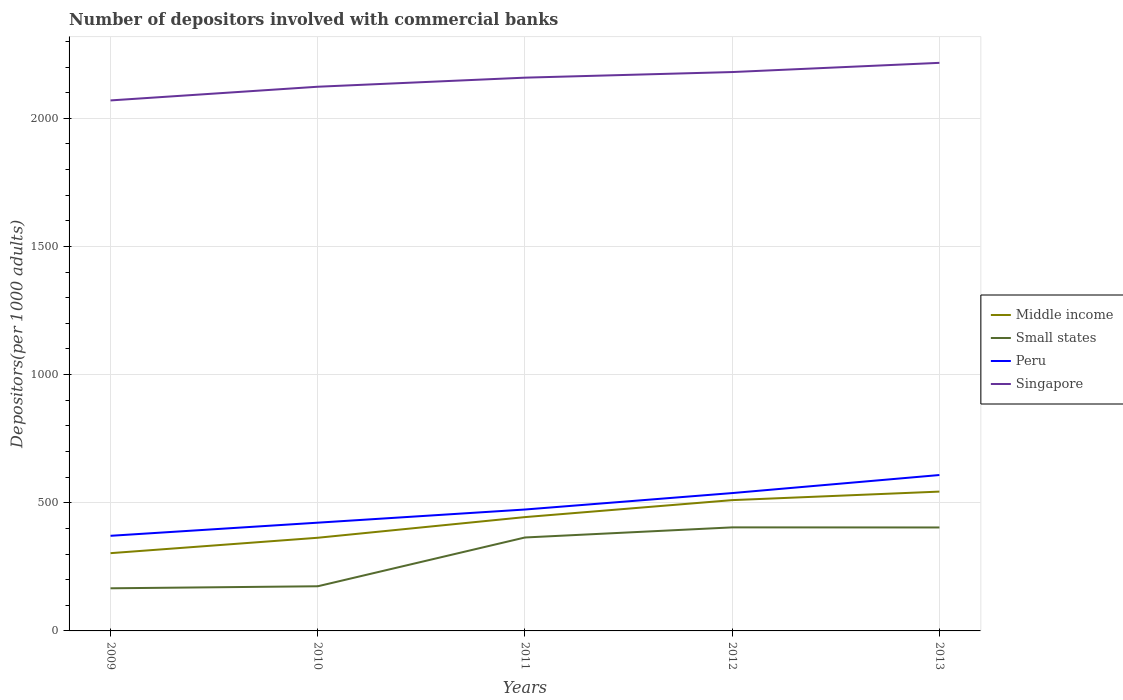How many different coloured lines are there?
Offer a very short reply. 4. Across all years, what is the maximum number of depositors involved with commercial banks in Singapore?
Provide a succinct answer. 2069.88. In which year was the number of depositors involved with commercial banks in Singapore maximum?
Provide a succinct answer. 2009. What is the total number of depositors involved with commercial banks in Singapore in the graph?
Ensure brevity in your answer.  -53.4. What is the difference between the highest and the second highest number of depositors involved with commercial banks in Small states?
Provide a succinct answer. 237.71. Is the number of depositors involved with commercial banks in Singapore strictly greater than the number of depositors involved with commercial banks in Peru over the years?
Keep it short and to the point. No. How many lines are there?
Give a very brief answer. 4. What is the difference between two consecutive major ticks on the Y-axis?
Provide a short and direct response. 500. Are the values on the major ticks of Y-axis written in scientific E-notation?
Offer a terse response. No. Does the graph contain grids?
Offer a terse response. Yes. How many legend labels are there?
Your response must be concise. 4. What is the title of the graph?
Keep it short and to the point. Number of depositors involved with commercial banks. Does "Armenia" appear as one of the legend labels in the graph?
Offer a very short reply. No. What is the label or title of the X-axis?
Keep it short and to the point. Years. What is the label or title of the Y-axis?
Provide a succinct answer. Depositors(per 1000 adults). What is the Depositors(per 1000 adults) of Middle income in 2009?
Make the answer very short. 303.38. What is the Depositors(per 1000 adults) in Small states in 2009?
Keep it short and to the point. 166.31. What is the Depositors(per 1000 adults) of Peru in 2009?
Offer a very short reply. 371.13. What is the Depositors(per 1000 adults) in Singapore in 2009?
Make the answer very short. 2069.88. What is the Depositors(per 1000 adults) in Middle income in 2010?
Make the answer very short. 363.5. What is the Depositors(per 1000 adults) in Small states in 2010?
Ensure brevity in your answer.  174.21. What is the Depositors(per 1000 adults) of Peru in 2010?
Offer a very short reply. 422.34. What is the Depositors(per 1000 adults) in Singapore in 2010?
Offer a terse response. 2123.28. What is the Depositors(per 1000 adults) in Middle income in 2011?
Your response must be concise. 444.11. What is the Depositors(per 1000 adults) in Small states in 2011?
Make the answer very short. 364.57. What is the Depositors(per 1000 adults) in Peru in 2011?
Offer a very short reply. 473.69. What is the Depositors(per 1000 adults) in Singapore in 2011?
Offer a very short reply. 2158.7. What is the Depositors(per 1000 adults) in Middle income in 2012?
Give a very brief answer. 510.34. What is the Depositors(per 1000 adults) of Small states in 2012?
Ensure brevity in your answer.  404.02. What is the Depositors(per 1000 adults) in Peru in 2012?
Give a very brief answer. 537.87. What is the Depositors(per 1000 adults) of Singapore in 2012?
Provide a succinct answer. 2180.57. What is the Depositors(per 1000 adults) in Middle income in 2013?
Make the answer very short. 543.59. What is the Depositors(per 1000 adults) in Small states in 2013?
Provide a short and direct response. 403.64. What is the Depositors(per 1000 adults) in Peru in 2013?
Your response must be concise. 608.29. What is the Depositors(per 1000 adults) of Singapore in 2013?
Your answer should be very brief. 2216.49. Across all years, what is the maximum Depositors(per 1000 adults) in Middle income?
Give a very brief answer. 543.59. Across all years, what is the maximum Depositors(per 1000 adults) in Small states?
Offer a very short reply. 404.02. Across all years, what is the maximum Depositors(per 1000 adults) of Peru?
Provide a short and direct response. 608.29. Across all years, what is the maximum Depositors(per 1000 adults) of Singapore?
Keep it short and to the point. 2216.49. Across all years, what is the minimum Depositors(per 1000 adults) in Middle income?
Your answer should be very brief. 303.38. Across all years, what is the minimum Depositors(per 1000 adults) of Small states?
Make the answer very short. 166.31. Across all years, what is the minimum Depositors(per 1000 adults) of Peru?
Give a very brief answer. 371.13. Across all years, what is the minimum Depositors(per 1000 adults) in Singapore?
Provide a short and direct response. 2069.88. What is the total Depositors(per 1000 adults) in Middle income in the graph?
Make the answer very short. 2164.92. What is the total Depositors(per 1000 adults) of Small states in the graph?
Your answer should be very brief. 1512.74. What is the total Depositors(per 1000 adults) of Peru in the graph?
Give a very brief answer. 2413.33. What is the total Depositors(per 1000 adults) in Singapore in the graph?
Your response must be concise. 1.07e+04. What is the difference between the Depositors(per 1000 adults) of Middle income in 2009 and that in 2010?
Make the answer very short. -60.11. What is the difference between the Depositors(per 1000 adults) of Small states in 2009 and that in 2010?
Your answer should be compact. -7.91. What is the difference between the Depositors(per 1000 adults) of Peru in 2009 and that in 2010?
Your answer should be very brief. -51.21. What is the difference between the Depositors(per 1000 adults) in Singapore in 2009 and that in 2010?
Offer a very short reply. -53.4. What is the difference between the Depositors(per 1000 adults) of Middle income in 2009 and that in 2011?
Your response must be concise. -140.73. What is the difference between the Depositors(per 1000 adults) in Small states in 2009 and that in 2011?
Your answer should be compact. -198.26. What is the difference between the Depositors(per 1000 adults) in Peru in 2009 and that in 2011?
Your answer should be very brief. -102.56. What is the difference between the Depositors(per 1000 adults) in Singapore in 2009 and that in 2011?
Ensure brevity in your answer.  -88.82. What is the difference between the Depositors(per 1000 adults) in Middle income in 2009 and that in 2012?
Provide a short and direct response. -206.95. What is the difference between the Depositors(per 1000 adults) of Small states in 2009 and that in 2012?
Offer a very short reply. -237.71. What is the difference between the Depositors(per 1000 adults) in Peru in 2009 and that in 2012?
Ensure brevity in your answer.  -166.74. What is the difference between the Depositors(per 1000 adults) in Singapore in 2009 and that in 2012?
Ensure brevity in your answer.  -110.69. What is the difference between the Depositors(per 1000 adults) of Middle income in 2009 and that in 2013?
Your answer should be compact. -240.21. What is the difference between the Depositors(per 1000 adults) in Small states in 2009 and that in 2013?
Give a very brief answer. -237.33. What is the difference between the Depositors(per 1000 adults) in Peru in 2009 and that in 2013?
Provide a short and direct response. -237.16. What is the difference between the Depositors(per 1000 adults) of Singapore in 2009 and that in 2013?
Offer a terse response. -146.61. What is the difference between the Depositors(per 1000 adults) in Middle income in 2010 and that in 2011?
Your answer should be compact. -80.61. What is the difference between the Depositors(per 1000 adults) of Small states in 2010 and that in 2011?
Offer a very short reply. -190.35. What is the difference between the Depositors(per 1000 adults) in Peru in 2010 and that in 2011?
Your response must be concise. -51.35. What is the difference between the Depositors(per 1000 adults) of Singapore in 2010 and that in 2011?
Provide a short and direct response. -35.42. What is the difference between the Depositors(per 1000 adults) in Middle income in 2010 and that in 2012?
Give a very brief answer. -146.84. What is the difference between the Depositors(per 1000 adults) of Small states in 2010 and that in 2012?
Ensure brevity in your answer.  -229.8. What is the difference between the Depositors(per 1000 adults) of Peru in 2010 and that in 2012?
Your response must be concise. -115.53. What is the difference between the Depositors(per 1000 adults) of Singapore in 2010 and that in 2012?
Offer a very short reply. -57.29. What is the difference between the Depositors(per 1000 adults) of Middle income in 2010 and that in 2013?
Your answer should be very brief. -180.09. What is the difference between the Depositors(per 1000 adults) of Small states in 2010 and that in 2013?
Keep it short and to the point. -229.42. What is the difference between the Depositors(per 1000 adults) of Peru in 2010 and that in 2013?
Your answer should be very brief. -185.95. What is the difference between the Depositors(per 1000 adults) in Singapore in 2010 and that in 2013?
Offer a very short reply. -93.21. What is the difference between the Depositors(per 1000 adults) of Middle income in 2011 and that in 2012?
Ensure brevity in your answer.  -66.23. What is the difference between the Depositors(per 1000 adults) of Small states in 2011 and that in 2012?
Your answer should be compact. -39.45. What is the difference between the Depositors(per 1000 adults) of Peru in 2011 and that in 2012?
Make the answer very short. -64.18. What is the difference between the Depositors(per 1000 adults) in Singapore in 2011 and that in 2012?
Make the answer very short. -21.87. What is the difference between the Depositors(per 1000 adults) of Middle income in 2011 and that in 2013?
Offer a very short reply. -99.48. What is the difference between the Depositors(per 1000 adults) in Small states in 2011 and that in 2013?
Offer a very short reply. -39.07. What is the difference between the Depositors(per 1000 adults) of Peru in 2011 and that in 2013?
Your answer should be very brief. -134.6. What is the difference between the Depositors(per 1000 adults) in Singapore in 2011 and that in 2013?
Offer a terse response. -57.79. What is the difference between the Depositors(per 1000 adults) in Middle income in 2012 and that in 2013?
Give a very brief answer. -33.25. What is the difference between the Depositors(per 1000 adults) in Small states in 2012 and that in 2013?
Provide a succinct answer. 0.38. What is the difference between the Depositors(per 1000 adults) in Peru in 2012 and that in 2013?
Provide a succinct answer. -70.42. What is the difference between the Depositors(per 1000 adults) in Singapore in 2012 and that in 2013?
Offer a very short reply. -35.92. What is the difference between the Depositors(per 1000 adults) in Middle income in 2009 and the Depositors(per 1000 adults) in Small states in 2010?
Provide a short and direct response. 129.17. What is the difference between the Depositors(per 1000 adults) of Middle income in 2009 and the Depositors(per 1000 adults) of Peru in 2010?
Ensure brevity in your answer.  -118.96. What is the difference between the Depositors(per 1000 adults) of Middle income in 2009 and the Depositors(per 1000 adults) of Singapore in 2010?
Give a very brief answer. -1819.89. What is the difference between the Depositors(per 1000 adults) of Small states in 2009 and the Depositors(per 1000 adults) of Peru in 2010?
Your response must be concise. -256.04. What is the difference between the Depositors(per 1000 adults) in Small states in 2009 and the Depositors(per 1000 adults) in Singapore in 2010?
Your answer should be very brief. -1956.97. What is the difference between the Depositors(per 1000 adults) of Peru in 2009 and the Depositors(per 1000 adults) of Singapore in 2010?
Keep it short and to the point. -1752.14. What is the difference between the Depositors(per 1000 adults) in Middle income in 2009 and the Depositors(per 1000 adults) in Small states in 2011?
Your answer should be compact. -61.18. What is the difference between the Depositors(per 1000 adults) in Middle income in 2009 and the Depositors(per 1000 adults) in Peru in 2011?
Ensure brevity in your answer.  -170.31. What is the difference between the Depositors(per 1000 adults) in Middle income in 2009 and the Depositors(per 1000 adults) in Singapore in 2011?
Provide a succinct answer. -1855.32. What is the difference between the Depositors(per 1000 adults) of Small states in 2009 and the Depositors(per 1000 adults) of Peru in 2011?
Your answer should be very brief. -307.38. What is the difference between the Depositors(per 1000 adults) in Small states in 2009 and the Depositors(per 1000 adults) in Singapore in 2011?
Make the answer very short. -1992.4. What is the difference between the Depositors(per 1000 adults) of Peru in 2009 and the Depositors(per 1000 adults) of Singapore in 2011?
Provide a short and direct response. -1787.57. What is the difference between the Depositors(per 1000 adults) in Middle income in 2009 and the Depositors(per 1000 adults) in Small states in 2012?
Your answer should be very brief. -100.63. What is the difference between the Depositors(per 1000 adults) of Middle income in 2009 and the Depositors(per 1000 adults) of Peru in 2012?
Keep it short and to the point. -234.49. What is the difference between the Depositors(per 1000 adults) in Middle income in 2009 and the Depositors(per 1000 adults) in Singapore in 2012?
Offer a terse response. -1877.19. What is the difference between the Depositors(per 1000 adults) in Small states in 2009 and the Depositors(per 1000 adults) in Peru in 2012?
Offer a very short reply. -371.56. What is the difference between the Depositors(per 1000 adults) of Small states in 2009 and the Depositors(per 1000 adults) of Singapore in 2012?
Your answer should be compact. -2014.26. What is the difference between the Depositors(per 1000 adults) in Peru in 2009 and the Depositors(per 1000 adults) in Singapore in 2012?
Ensure brevity in your answer.  -1809.44. What is the difference between the Depositors(per 1000 adults) of Middle income in 2009 and the Depositors(per 1000 adults) of Small states in 2013?
Your answer should be very brief. -100.25. What is the difference between the Depositors(per 1000 adults) of Middle income in 2009 and the Depositors(per 1000 adults) of Peru in 2013?
Provide a succinct answer. -304.91. What is the difference between the Depositors(per 1000 adults) of Middle income in 2009 and the Depositors(per 1000 adults) of Singapore in 2013?
Your response must be concise. -1913.11. What is the difference between the Depositors(per 1000 adults) of Small states in 2009 and the Depositors(per 1000 adults) of Peru in 2013?
Provide a short and direct response. -441.98. What is the difference between the Depositors(per 1000 adults) of Small states in 2009 and the Depositors(per 1000 adults) of Singapore in 2013?
Your answer should be compact. -2050.19. What is the difference between the Depositors(per 1000 adults) of Peru in 2009 and the Depositors(per 1000 adults) of Singapore in 2013?
Your response must be concise. -1845.36. What is the difference between the Depositors(per 1000 adults) of Middle income in 2010 and the Depositors(per 1000 adults) of Small states in 2011?
Give a very brief answer. -1.07. What is the difference between the Depositors(per 1000 adults) in Middle income in 2010 and the Depositors(per 1000 adults) in Peru in 2011?
Provide a short and direct response. -110.19. What is the difference between the Depositors(per 1000 adults) in Middle income in 2010 and the Depositors(per 1000 adults) in Singapore in 2011?
Ensure brevity in your answer.  -1795.21. What is the difference between the Depositors(per 1000 adults) in Small states in 2010 and the Depositors(per 1000 adults) in Peru in 2011?
Offer a very short reply. -299.48. What is the difference between the Depositors(per 1000 adults) in Small states in 2010 and the Depositors(per 1000 adults) in Singapore in 2011?
Your answer should be compact. -1984.49. What is the difference between the Depositors(per 1000 adults) of Peru in 2010 and the Depositors(per 1000 adults) of Singapore in 2011?
Make the answer very short. -1736.36. What is the difference between the Depositors(per 1000 adults) in Middle income in 2010 and the Depositors(per 1000 adults) in Small states in 2012?
Offer a very short reply. -40.52. What is the difference between the Depositors(per 1000 adults) of Middle income in 2010 and the Depositors(per 1000 adults) of Peru in 2012?
Give a very brief answer. -174.37. What is the difference between the Depositors(per 1000 adults) in Middle income in 2010 and the Depositors(per 1000 adults) in Singapore in 2012?
Provide a succinct answer. -1817.07. What is the difference between the Depositors(per 1000 adults) in Small states in 2010 and the Depositors(per 1000 adults) in Peru in 2012?
Provide a short and direct response. -363.66. What is the difference between the Depositors(per 1000 adults) in Small states in 2010 and the Depositors(per 1000 adults) in Singapore in 2012?
Ensure brevity in your answer.  -2006.36. What is the difference between the Depositors(per 1000 adults) of Peru in 2010 and the Depositors(per 1000 adults) of Singapore in 2012?
Your response must be concise. -1758.23. What is the difference between the Depositors(per 1000 adults) in Middle income in 2010 and the Depositors(per 1000 adults) in Small states in 2013?
Your response must be concise. -40.14. What is the difference between the Depositors(per 1000 adults) in Middle income in 2010 and the Depositors(per 1000 adults) in Peru in 2013?
Your answer should be very brief. -244.79. What is the difference between the Depositors(per 1000 adults) of Middle income in 2010 and the Depositors(per 1000 adults) of Singapore in 2013?
Provide a short and direct response. -1853. What is the difference between the Depositors(per 1000 adults) in Small states in 2010 and the Depositors(per 1000 adults) in Peru in 2013?
Offer a terse response. -434.08. What is the difference between the Depositors(per 1000 adults) of Small states in 2010 and the Depositors(per 1000 adults) of Singapore in 2013?
Provide a short and direct response. -2042.28. What is the difference between the Depositors(per 1000 adults) in Peru in 2010 and the Depositors(per 1000 adults) in Singapore in 2013?
Keep it short and to the point. -1794.15. What is the difference between the Depositors(per 1000 adults) in Middle income in 2011 and the Depositors(per 1000 adults) in Small states in 2012?
Provide a short and direct response. 40.09. What is the difference between the Depositors(per 1000 adults) of Middle income in 2011 and the Depositors(per 1000 adults) of Peru in 2012?
Your response must be concise. -93.76. What is the difference between the Depositors(per 1000 adults) in Middle income in 2011 and the Depositors(per 1000 adults) in Singapore in 2012?
Offer a very short reply. -1736.46. What is the difference between the Depositors(per 1000 adults) in Small states in 2011 and the Depositors(per 1000 adults) in Peru in 2012?
Make the answer very short. -173.3. What is the difference between the Depositors(per 1000 adults) in Small states in 2011 and the Depositors(per 1000 adults) in Singapore in 2012?
Your answer should be compact. -1816. What is the difference between the Depositors(per 1000 adults) in Peru in 2011 and the Depositors(per 1000 adults) in Singapore in 2012?
Offer a very short reply. -1706.88. What is the difference between the Depositors(per 1000 adults) of Middle income in 2011 and the Depositors(per 1000 adults) of Small states in 2013?
Your answer should be very brief. 40.47. What is the difference between the Depositors(per 1000 adults) in Middle income in 2011 and the Depositors(per 1000 adults) in Peru in 2013?
Provide a short and direct response. -164.18. What is the difference between the Depositors(per 1000 adults) of Middle income in 2011 and the Depositors(per 1000 adults) of Singapore in 2013?
Provide a short and direct response. -1772.38. What is the difference between the Depositors(per 1000 adults) of Small states in 2011 and the Depositors(per 1000 adults) of Peru in 2013?
Provide a succinct answer. -243.72. What is the difference between the Depositors(per 1000 adults) of Small states in 2011 and the Depositors(per 1000 adults) of Singapore in 2013?
Offer a very short reply. -1851.92. What is the difference between the Depositors(per 1000 adults) of Peru in 2011 and the Depositors(per 1000 adults) of Singapore in 2013?
Your response must be concise. -1742.8. What is the difference between the Depositors(per 1000 adults) in Middle income in 2012 and the Depositors(per 1000 adults) in Small states in 2013?
Your response must be concise. 106.7. What is the difference between the Depositors(per 1000 adults) in Middle income in 2012 and the Depositors(per 1000 adults) in Peru in 2013?
Offer a terse response. -97.96. What is the difference between the Depositors(per 1000 adults) in Middle income in 2012 and the Depositors(per 1000 adults) in Singapore in 2013?
Provide a succinct answer. -1706.16. What is the difference between the Depositors(per 1000 adults) of Small states in 2012 and the Depositors(per 1000 adults) of Peru in 2013?
Give a very brief answer. -204.27. What is the difference between the Depositors(per 1000 adults) in Small states in 2012 and the Depositors(per 1000 adults) in Singapore in 2013?
Your response must be concise. -1812.48. What is the difference between the Depositors(per 1000 adults) in Peru in 2012 and the Depositors(per 1000 adults) in Singapore in 2013?
Provide a short and direct response. -1678.62. What is the average Depositors(per 1000 adults) of Middle income per year?
Offer a very short reply. 432.98. What is the average Depositors(per 1000 adults) in Small states per year?
Give a very brief answer. 302.55. What is the average Depositors(per 1000 adults) in Peru per year?
Provide a succinct answer. 482.67. What is the average Depositors(per 1000 adults) of Singapore per year?
Offer a very short reply. 2149.78. In the year 2009, what is the difference between the Depositors(per 1000 adults) of Middle income and Depositors(per 1000 adults) of Small states?
Offer a very short reply. 137.08. In the year 2009, what is the difference between the Depositors(per 1000 adults) in Middle income and Depositors(per 1000 adults) in Peru?
Ensure brevity in your answer.  -67.75. In the year 2009, what is the difference between the Depositors(per 1000 adults) in Middle income and Depositors(per 1000 adults) in Singapore?
Keep it short and to the point. -1766.49. In the year 2009, what is the difference between the Depositors(per 1000 adults) of Small states and Depositors(per 1000 adults) of Peru?
Keep it short and to the point. -204.83. In the year 2009, what is the difference between the Depositors(per 1000 adults) of Small states and Depositors(per 1000 adults) of Singapore?
Your response must be concise. -1903.57. In the year 2009, what is the difference between the Depositors(per 1000 adults) in Peru and Depositors(per 1000 adults) in Singapore?
Ensure brevity in your answer.  -1698.74. In the year 2010, what is the difference between the Depositors(per 1000 adults) in Middle income and Depositors(per 1000 adults) in Small states?
Your answer should be very brief. 189.28. In the year 2010, what is the difference between the Depositors(per 1000 adults) in Middle income and Depositors(per 1000 adults) in Peru?
Offer a very short reply. -58.85. In the year 2010, what is the difference between the Depositors(per 1000 adults) of Middle income and Depositors(per 1000 adults) of Singapore?
Offer a very short reply. -1759.78. In the year 2010, what is the difference between the Depositors(per 1000 adults) in Small states and Depositors(per 1000 adults) in Peru?
Offer a terse response. -248.13. In the year 2010, what is the difference between the Depositors(per 1000 adults) in Small states and Depositors(per 1000 adults) in Singapore?
Keep it short and to the point. -1949.06. In the year 2010, what is the difference between the Depositors(per 1000 adults) of Peru and Depositors(per 1000 adults) of Singapore?
Your answer should be very brief. -1700.94. In the year 2011, what is the difference between the Depositors(per 1000 adults) of Middle income and Depositors(per 1000 adults) of Small states?
Ensure brevity in your answer.  79.54. In the year 2011, what is the difference between the Depositors(per 1000 adults) of Middle income and Depositors(per 1000 adults) of Peru?
Your answer should be compact. -29.58. In the year 2011, what is the difference between the Depositors(per 1000 adults) in Middle income and Depositors(per 1000 adults) in Singapore?
Offer a terse response. -1714.59. In the year 2011, what is the difference between the Depositors(per 1000 adults) of Small states and Depositors(per 1000 adults) of Peru?
Your response must be concise. -109.12. In the year 2011, what is the difference between the Depositors(per 1000 adults) of Small states and Depositors(per 1000 adults) of Singapore?
Provide a succinct answer. -1794.13. In the year 2011, what is the difference between the Depositors(per 1000 adults) of Peru and Depositors(per 1000 adults) of Singapore?
Ensure brevity in your answer.  -1685.01. In the year 2012, what is the difference between the Depositors(per 1000 adults) of Middle income and Depositors(per 1000 adults) of Small states?
Provide a short and direct response. 106.32. In the year 2012, what is the difference between the Depositors(per 1000 adults) of Middle income and Depositors(per 1000 adults) of Peru?
Make the answer very short. -27.53. In the year 2012, what is the difference between the Depositors(per 1000 adults) in Middle income and Depositors(per 1000 adults) in Singapore?
Your answer should be compact. -1670.23. In the year 2012, what is the difference between the Depositors(per 1000 adults) of Small states and Depositors(per 1000 adults) of Peru?
Keep it short and to the point. -133.85. In the year 2012, what is the difference between the Depositors(per 1000 adults) of Small states and Depositors(per 1000 adults) of Singapore?
Offer a very short reply. -1776.55. In the year 2012, what is the difference between the Depositors(per 1000 adults) of Peru and Depositors(per 1000 adults) of Singapore?
Ensure brevity in your answer.  -1642.7. In the year 2013, what is the difference between the Depositors(per 1000 adults) of Middle income and Depositors(per 1000 adults) of Small states?
Provide a succinct answer. 139.95. In the year 2013, what is the difference between the Depositors(per 1000 adults) of Middle income and Depositors(per 1000 adults) of Peru?
Offer a very short reply. -64.7. In the year 2013, what is the difference between the Depositors(per 1000 adults) of Middle income and Depositors(per 1000 adults) of Singapore?
Your response must be concise. -1672.9. In the year 2013, what is the difference between the Depositors(per 1000 adults) in Small states and Depositors(per 1000 adults) in Peru?
Make the answer very short. -204.65. In the year 2013, what is the difference between the Depositors(per 1000 adults) of Small states and Depositors(per 1000 adults) of Singapore?
Your answer should be compact. -1812.85. In the year 2013, what is the difference between the Depositors(per 1000 adults) in Peru and Depositors(per 1000 adults) in Singapore?
Keep it short and to the point. -1608.2. What is the ratio of the Depositors(per 1000 adults) of Middle income in 2009 to that in 2010?
Make the answer very short. 0.83. What is the ratio of the Depositors(per 1000 adults) of Small states in 2009 to that in 2010?
Offer a terse response. 0.95. What is the ratio of the Depositors(per 1000 adults) of Peru in 2009 to that in 2010?
Ensure brevity in your answer.  0.88. What is the ratio of the Depositors(per 1000 adults) in Singapore in 2009 to that in 2010?
Ensure brevity in your answer.  0.97. What is the ratio of the Depositors(per 1000 adults) in Middle income in 2009 to that in 2011?
Ensure brevity in your answer.  0.68. What is the ratio of the Depositors(per 1000 adults) of Small states in 2009 to that in 2011?
Your answer should be very brief. 0.46. What is the ratio of the Depositors(per 1000 adults) of Peru in 2009 to that in 2011?
Your answer should be compact. 0.78. What is the ratio of the Depositors(per 1000 adults) in Singapore in 2009 to that in 2011?
Your answer should be very brief. 0.96. What is the ratio of the Depositors(per 1000 adults) in Middle income in 2009 to that in 2012?
Ensure brevity in your answer.  0.59. What is the ratio of the Depositors(per 1000 adults) in Small states in 2009 to that in 2012?
Your answer should be compact. 0.41. What is the ratio of the Depositors(per 1000 adults) in Peru in 2009 to that in 2012?
Make the answer very short. 0.69. What is the ratio of the Depositors(per 1000 adults) in Singapore in 2009 to that in 2012?
Provide a succinct answer. 0.95. What is the ratio of the Depositors(per 1000 adults) in Middle income in 2009 to that in 2013?
Offer a terse response. 0.56. What is the ratio of the Depositors(per 1000 adults) of Small states in 2009 to that in 2013?
Offer a very short reply. 0.41. What is the ratio of the Depositors(per 1000 adults) of Peru in 2009 to that in 2013?
Ensure brevity in your answer.  0.61. What is the ratio of the Depositors(per 1000 adults) of Singapore in 2009 to that in 2013?
Provide a succinct answer. 0.93. What is the ratio of the Depositors(per 1000 adults) in Middle income in 2010 to that in 2011?
Your answer should be very brief. 0.82. What is the ratio of the Depositors(per 1000 adults) of Small states in 2010 to that in 2011?
Your answer should be compact. 0.48. What is the ratio of the Depositors(per 1000 adults) in Peru in 2010 to that in 2011?
Your response must be concise. 0.89. What is the ratio of the Depositors(per 1000 adults) in Singapore in 2010 to that in 2011?
Ensure brevity in your answer.  0.98. What is the ratio of the Depositors(per 1000 adults) of Middle income in 2010 to that in 2012?
Give a very brief answer. 0.71. What is the ratio of the Depositors(per 1000 adults) in Small states in 2010 to that in 2012?
Give a very brief answer. 0.43. What is the ratio of the Depositors(per 1000 adults) in Peru in 2010 to that in 2012?
Provide a succinct answer. 0.79. What is the ratio of the Depositors(per 1000 adults) in Singapore in 2010 to that in 2012?
Give a very brief answer. 0.97. What is the ratio of the Depositors(per 1000 adults) of Middle income in 2010 to that in 2013?
Your answer should be compact. 0.67. What is the ratio of the Depositors(per 1000 adults) in Small states in 2010 to that in 2013?
Provide a succinct answer. 0.43. What is the ratio of the Depositors(per 1000 adults) in Peru in 2010 to that in 2013?
Your answer should be very brief. 0.69. What is the ratio of the Depositors(per 1000 adults) in Singapore in 2010 to that in 2013?
Offer a very short reply. 0.96. What is the ratio of the Depositors(per 1000 adults) in Middle income in 2011 to that in 2012?
Give a very brief answer. 0.87. What is the ratio of the Depositors(per 1000 adults) of Small states in 2011 to that in 2012?
Your answer should be compact. 0.9. What is the ratio of the Depositors(per 1000 adults) in Peru in 2011 to that in 2012?
Offer a very short reply. 0.88. What is the ratio of the Depositors(per 1000 adults) in Middle income in 2011 to that in 2013?
Provide a short and direct response. 0.82. What is the ratio of the Depositors(per 1000 adults) in Small states in 2011 to that in 2013?
Provide a succinct answer. 0.9. What is the ratio of the Depositors(per 1000 adults) in Peru in 2011 to that in 2013?
Offer a very short reply. 0.78. What is the ratio of the Depositors(per 1000 adults) in Singapore in 2011 to that in 2013?
Offer a terse response. 0.97. What is the ratio of the Depositors(per 1000 adults) in Middle income in 2012 to that in 2013?
Your answer should be compact. 0.94. What is the ratio of the Depositors(per 1000 adults) in Peru in 2012 to that in 2013?
Keep it short and to the point. 0.88. What is the ratio of the Depositors(per 1000 adults) of Singapore in 2012 to that in 2013?
Your response must be concise. 0.98. What is the difference between the highest and the second highest Depositors(per 1000 adults) of Middle income?
Keep it short and to the point. 33.25. What is the difference between the highest and the second highest Depositors(per 1000 adults) of Small states?
Your answer should be very brief. 0.38. What is the difference between the highest and the second highest Depositors(per 1000 adults) in Peru?
Your answer should be very brief. 70.42. What is the difference between the highest and the second highest Depositors(per 1000 adults) in Singapore?
Provide a short and direct response. 35.92. What is the difference between the highest and the lowest Depositors(per 1000 adults) of Middle income?
Offer a terse response. 240.21. What is the difference between the highest and the lowest Depositors(per 1000 adults) in Small states?
Ensure brevity in your answer.  237.71. What is the difference between the highest and the lowest Depositors(per 1000 adults) in Peru?
Provide a short and direct response. 237.16. What is the difference between the highest and the lowest Depositors(per 1000 adults) of Singapore?
Provide a short and direct response. 146.61. 